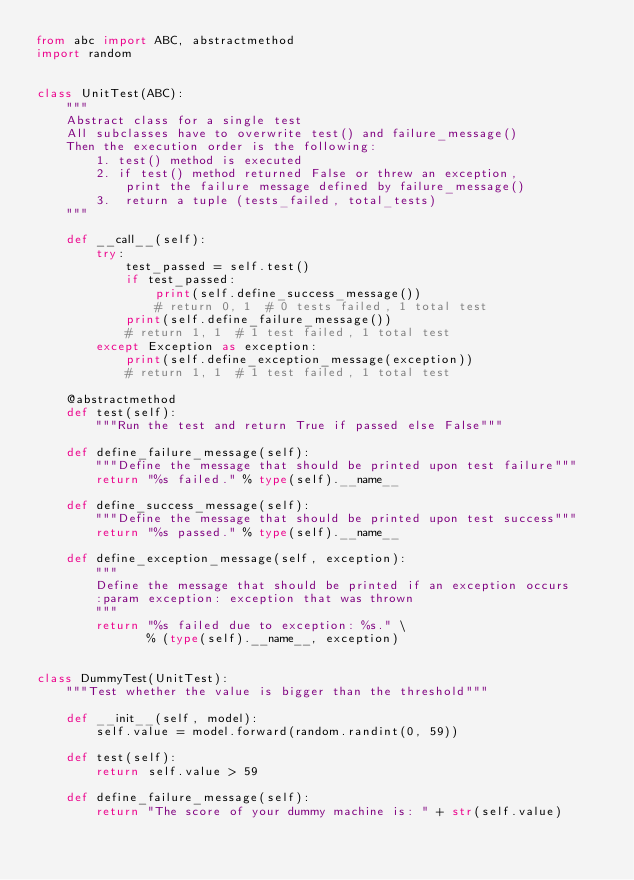Convert code to text. <code><loc_0><loc_0><loc_500><loc_500><_Python_>from abc import ABC, abstractmethod
import random


class UnitTest(ABC):
    """
    Abstract class for a single test
    All subclasses have to overwrite test() and failure_message()
    Then the execution order is the following:
        1. test() method is executed
        2. if test() method returned False or threw an exception,
            print the failure message defined by failure_message()
        3.  return a tuple (tests_failed, total_tests)
    """

    def __call__(self):
        try:
            test_passed = self.test()
            if test_passed:
                print(self.define_success_message())
                # return 0, 1  # 0 tests failed, 1 total test
            print(self.define_failure_message())
            # return 1, 1  # 1 test failed, 1 total test
        except Exception as exception:
            print(self.define_exception_message(exception))
            # return 1, 1  # 1 test failed, 1 total test

    @abstractmethod
    def test(self):
        """Run the test and return True if passed else False"""

    def define_failure_message(self):
        """Define the message that should be printed upon test failure"""
        return "%s failed." % type(self).__name__

    def define_success_message(self):
        """Define the message that should be printed upon test success"""
        return "%s passed." % type(self).__name__

    def define_exception_message(self, exception):
        """
        Define the message that should be printed if an exception occurs
        :param exception: exception that was thrown
        """
        return "%s failed due to exception: %s." \
               % (type(self).__name__, exception)


class DummyTest(UnitTest):
    """Test whether the value is bigger than the threshold"""

    def __init__(self, model):
        self.value = model.forward(random.randint(0, 59))

    def test(self):
        return self.value > 59

    def define_failure_message(self):
        return "The score of your dummy machine is: " + str(self.value)
</code> 